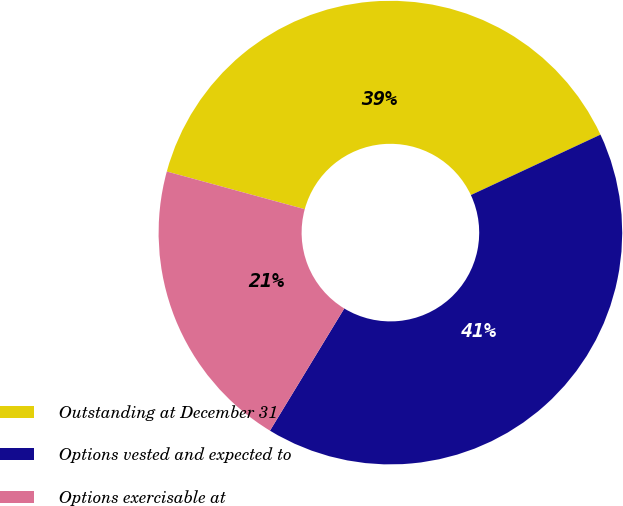Convert chart. <chart><loc_0><loc_0><loc_500><loc_500><pie_chart><fcel>Outstanding at December 31<fcel>Options vested and expected to<fcel>Options exercisable at<nl><fcel>38.81%<fcel>40.64%<fcel>20.55%<nl></chart> 